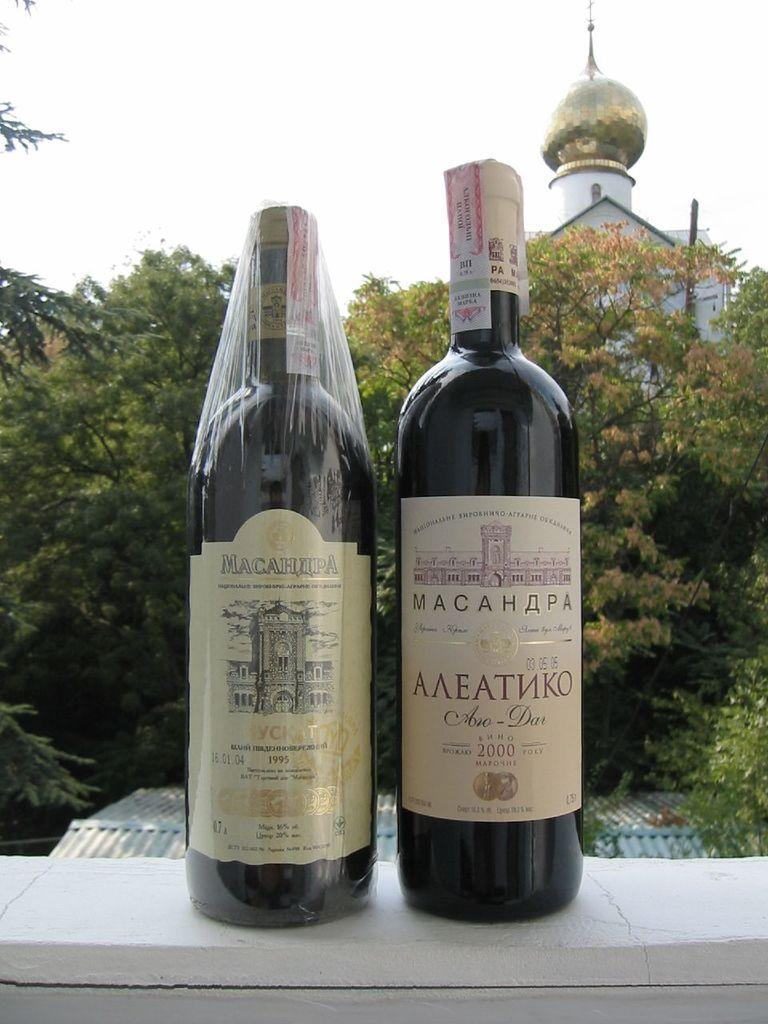<image>
Share a concise interpretation of the image provided. Two bottles of Russian wine are from the years 1995 and 2000. 